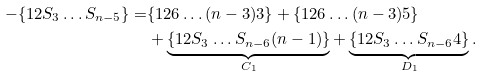Convert formula to latex. <formula><loc_0><loc_0><loc_500><loc_500>- \{ 1 2 S _ { 3 } \dots S _ { n - 5 } \} = & \{ 1 2 6 \dots ( n - 3 ) 3 \} + \{ 1 2 6 \dots ( n - 3 ) 5 \} \\ & + \underbrace { \{ 1 2 S _ { 3 } \dots S _ { n - 6 } ( n - 1 ) \} } _ { C _ { 1 } } + \underbrace { \{ 1 2 S _ { 3 } \dots S _ { n - 6 } 4 \} } _ { D _ { 1 } } .</formula> 